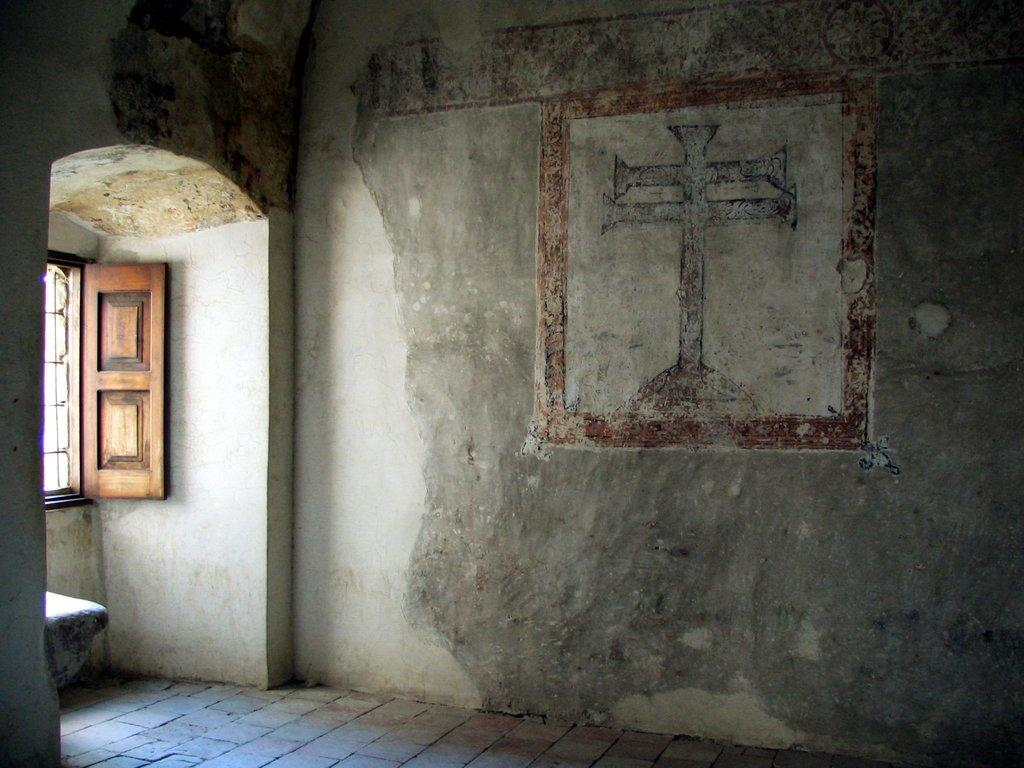What type of location is depicted in the image? The image shows an inside view of a building. What can be seen on the wall in the background? There is a painting on the wall in the background. Is there any natural light source visible in the image? Yes, there is a window in the background. What type of wrench is being used by the group in the image? There is no group or wrench present in the image; it shows an inside view of a building with a painting on the wall and a window in the background. 